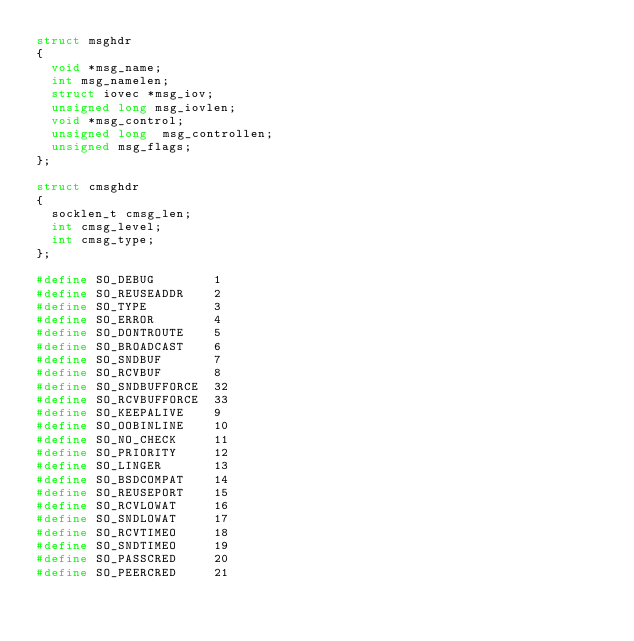<code> <loc_0><loc_0><loc_500><loc_500><_C_>struct msghdr
{
	void *msg_name;
	int msg_namelen;
	struct iovec *msg_iov;
	unsigned long msg_iovlen;
	void *msg_control;
	unsigned long  msg_controllen;
	unsigned msg_flags;
};

struct cmsghdr
{
	socklen_t cmsg_len;
	int cmsg_level;
	int cmsg_type;
};

#define SO_DEBUG        1
#define SO_REUSEADDR    2
#define SO_TYPE         3
#define SO_ERROR        4
#define SO_DONTROUTE    5
#define SO_BROADCAST    6
#define SO_SNDBUF       7
#define SO_RCVBUF       8
#define SO_SNDBUFFORCE  32
#define SO_RCVBUFFORCE  33
#define SO_KEEPALIVE    9
#define SO_OOBINLINE    10
#define SO_NO_CHECK     11
#define SO_PRIORITY     12
#define SO_LINGER       13
#define SO_BSDCOMPAT    14
#define SO_REUSEPORT    15
#define SO_RCVLOWAT     16
#define SO_SNDLOWAT     17
#define SO_RCVTIMEO     18
#define SO_SNDTIMEO     19
#define SO_PASSCRED     20
#define SO_PEERCRED     21
 
</code> 